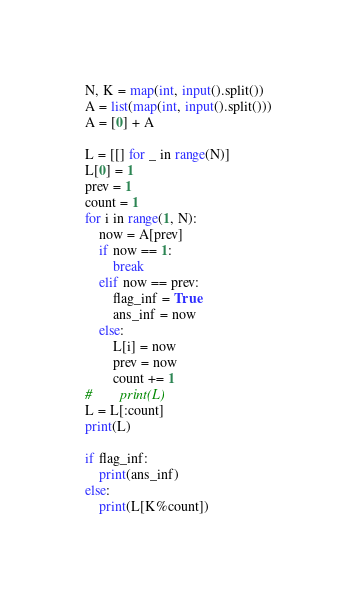<code> <loc_0><loc_0><loc_500><loc_500><_Python_>N, K = map(int, input().split())
A = list(map(int, input().split()))
A = [0] + A

L = [[] for _ in range(N)]
L[0] = 1
prev = 1
count = 1
for i in range(1, N):
    now = A[prev]
    if now == 1:
        break
    elif now == prev:
        flag_inf = True
        ans_inf = now
    else:
        L[i] = now
        prev = now
        count += 1
#        print(L)
L = L[:count]
print(L)

if flag_inf:
    print(ans_inf)
else:
    print(L[K%count])</code> 